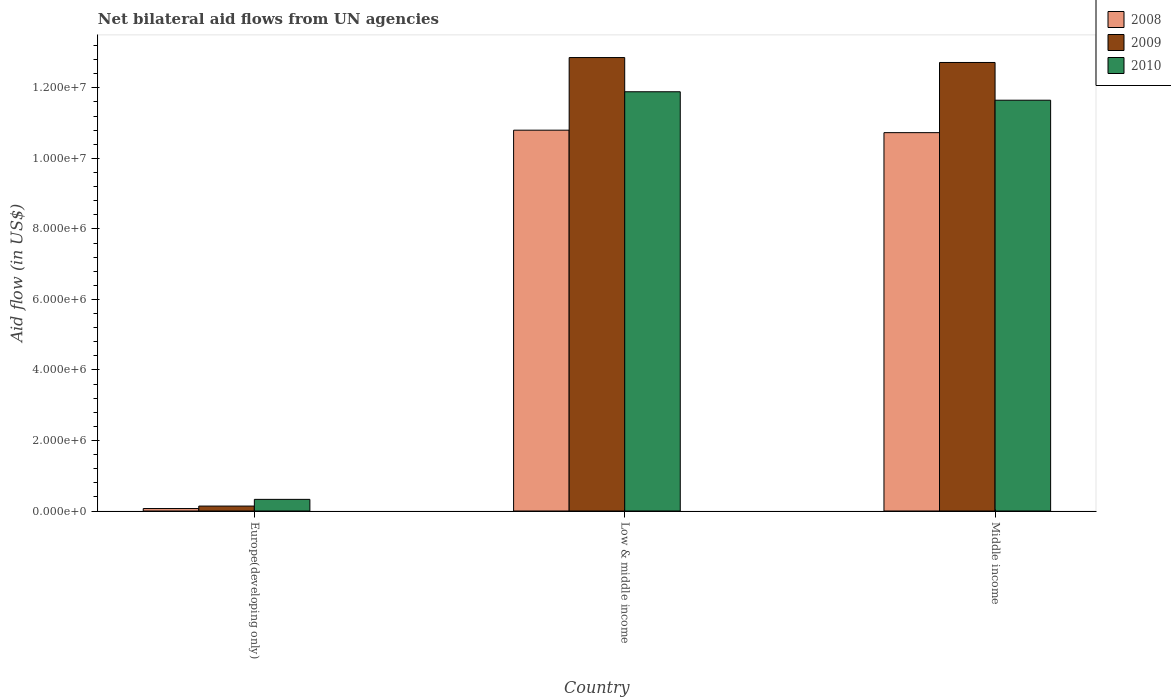How many bars are there on the 1st tick from the right?
Ensure brevity in your answer.  3. In how many cases, is the number of bars for a given country not equal to the number of legend labels?
Provide a succinct answer. 0. What is the net bilateral aid flow in 2008 in Middle income?
Keep it short and to the point. 1.07e+07. Across all countries, what is the maximum net bilateral aid flow in 2009?
Make the answer very short. 1.29e+07. In which country was the net bilateral aid flow in 2008 minimum?
Keep it short and to the point. Europe(developing only). What is the total net bilateral aid flow in 2008 in the graph?
Your response must be concise. 2.16e+07. What is the difference between the net bilateral aid flow in 2009 in Europe(developing only) and that in Low & middle income?
Give a very brief answer. -1.27e+07. What is the difference between the net bilateral aid flow in 2008 in Middle income and the net bilateral aid flow in 2010 in Low & middle income?
Your answer should be very brief. -1.16e+06. What is the average net bilateral aid flow in 2010 per country?
Make the answer very short. 7.96e+06. What is the difference between the net bilateral aid flow of/in 2010 and net bilateral aid flow of/in 2009 in Middle income?
Make the answer very short. -1.07e+06. What is the ratio of the net bilateral aid flow in 2010 in Low & middle income to that in Middle income?
Give a very brief answer. 1.02. Is the net bilateral aid flow in 2008 in Europe(developing only) less than that in Middle income?
Ensure brevity in your answer.  Yes. Is the difference between the net bilateral aid flow in 2010 in Low & middle income and Middle income greater than the difference between the net bilateral aid flow in 2009 in Low & middle income and Middle income?
Give a very brief answer. Yes. What is the difference between the highest and the second highest net bilateral aid flow in 2009?
Give a very brief answer. 1.27e+07. What is the difference between the highest and the lowest net bilateral aid flow in 2008?
Offer a very short reply. 1.07e+07. In how many countries, is the net bilateral aid flow in 2009 greater than the average net bilateral aid flow in 2009 taken over all countries?
Offer a terse response. 2. Is the sum of the net bilateral aid flow in 2010 in Low & middle income and Middle income greater than the maximum net bilateral aid flow in 2009 across all countries?
Your answer should be compact. Yes. What does the 1st bar from the left in Middle income represents?
Give a very brief answer. 2008. What does the 3rd bar from the right in Middle income represents?
Your answer should be very brief. 2008. How many bars are there?
Provide a short and direct response. 9. Are all the bars in the graph horizontal?
Offer a very short reply. No. How many countries are there in the graph?
Offer a very short reply. 3. What is the difference between two consecutive major ticks on the Y-axis?
Provide a short and direct response. 2.00e+06. Does the graph contain any zero values?
Offer a terse response. No. Where does the legend appear in the graph?
Offer a terse response. Top right. What is the title of the graph?
Offer a terse response. Net bilateral aid flows from UN agencies. What is the label or title of the Y-axis?
Provide a short and direct response. Aid flow (in US$). What is the Aid flow (in US$) of 2009 in Europe(developing only)?
Ensure brevity in your answer.  1.40e+05. What is the Aid flow (in US$) of 2010 in Europe(developing only)?
Make the answer very short. 3.30e+05. What is the Aid flow (in US$) in 2008 in Low & middle income?
Keep it short and to the point. 1.08e+07. What is the Aid flow (in US$) in 2009 in Low & middle income?
Your answer should be compact. 1.29e+07. What is the Aid flow (in US$) of 2010 in Low & middle income?
Your response must be concise. 1.19e+07. What is the Aid flow (in US$) of 2008 in Middle income?
Offer a terse response. 1.07e+07. What is the Aid flow (in US$) of 2009 in Middle income?
Offer a terse response. 1.27e+07. What is the Aid flow (in US$) of 2010 in Middle income?
Your response must be concise. 1.16e+07. Across all countries, what is the maximum Aid flow (in US$) of 2008?
Your response must be concise. 1.08e+07. Across all countries, what is the maximum Aid flow (in US$) in 2009?
Your response must be concise. 1.29e+07. Across all countries, what is the maximum Aid flow (in US$) in 2010?
Offer a very short reply. 1.19e+07. Across all countries, what is the minimum Aid flow (in US$) of 2010?
Give a very brief answer. 3.30e+05. What is the total Aid flow (in US$) in 2008 in the graph?
Provide a succinct answer. 2.16e+07. What is the total Aid flow (in US$) in 2009 in the graph?
Keep it short and to the point. 2.57e+07. What is the total Aid flow (in US$) of 2010 in the graph?
Your answer should be very brief. 2.39e+07. What is the difference between the Aid flow (in US$) of 2008 in Europe(developing only) and that in Low & middle income?
Offer a terse response. -1.07e+07. What is the difference between the Aid flow (in US$) in 2009 in Europe(developing only) and that in Low & middle income?
Your answer should be very brief. -1.27e+07. What is the difference between the Aid flow (in US$) in 2010 in Europe(developing only) and that in Low & middle income?
Keep it short and to the point. -1.16e+07. What is the difference between the Aid flow (in US$) of 2008 in Europe(developing only) and that in Middle income?
Your answer should be very brief. -1.07e+07. What is the difference between the Aid flow (in US$) of 2009 in Europe(developing only) and that in Middle income?
Give a very brief answer. -1.26e+07. What is the difference between the Aid flow (in US$) of 2010 in Europe(developing only) and that in Middle income?
Provide a succinct answer. -1.13e+07. What is the difference between the Aid flow (in US$) in 2008 in Low & middle income and that in Middle income?
Ensure brevity in your answer.  7.00e+04. What is the difference between the Aid flow (in US$) of 2009 in Low & middle income and that in Middle income?
Provide a short and direct response. 1.40e+05. What is the difference between the Aid flow (in US$) of 2010 in Low & middle income and that in Middle income?
Your answer should be very brief. 2.40e+05. What is the difference between the Aid flow (in US$) in 2008 in Europe(developing only) and the Aid flow (in US$) in 2009 in Low & middle income?
Your answer should be compact. -1.28e+07. What is the difference between the Aid flow (in US$) in 2008 in Europe(developing only) and the Aid flow (in US$) in 2010 in Low & middle income?
Make the answer very short. -1.18e+07. What is the difference between the Aid flow (in US$) in 2009 in Europe(developing only) and the Aid flow (in US$) in 2010 in Low & middle income?
Provide a short and direct response. -1.18e+07. What is the difference between the Aid flow (in US$) in 2008 in Europe(developing only) and the Aid flow (in US$) in 2009 in Middle income?
Provide a short and direct response. -1.26e+07. What is the difference between the Aid flow (in US$) of 2008 in Europe(developing only) and the Aid flow (in US$) of 2010 in Middle income?
Give a very brief answer. -1.16e+07. What is the difference between the Aid flow (in US$) of 2009 in Europe(developing only) and the Aid flow (in US$) of 2010 in Middle income?
Ensure brevity in your answer.  -1.15e+07. What is the difference between the Aid flow (in US$) of 2008 in Low & middle income and the Aid flow (in US$) of 2009 in Middle income?
Provide a short and direct response. -1.92e+06. What is the difference between the Aid flow (in US$) of 2008 in Low & middle income and the Aid flow (in US$) of 2010 in Middle income?
Give a very brief answer. -8.50e+05. What is the difference between the Aid flow (in US$) in 2009 in Low & middle income and the Aid flow (in US$) in 2010 in Middle income?
Your response must be concise. 1.21e+06. What is the average Aid flow (in US$) in 2008 per country?
Make the answer very short. 7.20e+06. What is the average Aid flow (in US$) of 2009 per country?
Offer a terse response. 8.57e+06. What is the average Aid flow (in US$) of 2010 per country?
Keep it short and to the point. 7.96e+06. What is the difference between the Aid flow (in US$) of 2008 and Aid flow (in US$) of 2009 in Europe(developing only)?
Keep it short and to the point. -7.00e+04. What is the difference between the Aid flow (in US$) of 2009 and Aid flow (in US$) of 2010 in Europe(developing only)?
Your response must be concise. -1.90e+05. What is the difference between the Aid flow (in US$) of 2008 and Aid flow (in US$) of 2009 in Low & middle income?
Offer a very short reply. -2.06e+06. What is the difference between the Aid flow (in US$) of 2008 and Aid flow (in US$) of 2010 in Low & middle income?
Make the answer very short. -1.09e+06. What is the difference between the Aid flow (in US$) of 2009 and Aid flow (in US$) of 2010 in Low & middle income?
Give a very brief answer. 9.70e+05. What is the difference between the Aid flow (in US$) in 2008 and Aid flow (in US$) in 2009 in Middle income?
Your answer should be very brief. -1.99e+06. What is the difference between the Aid flow (in US$) in 2008 and Aid flow (in US$) in 2010 in Middle income?
Your response must be concise. -9.20e+05. What is the difference between the Aid flow (in US$) of 2009 and Aid flow (in US$) of 2010 in Middle income?
Offer a very short reply. 1.07e+06. What is the ratio of the Aid flow (in US$) in 2008 in Europe(developing only) to that in Low & middle income?
Your response must be concise. 0.01. What is the ratio of the Aid flow (in US$) of 2009 in Europe(developing only) to that in Low & middle income?
Give a very brief answer. 0.01. What is the ratio of the Aid flow (in US$) of 2010 in Europe(developing only) to that in Low & middle income?
Offer a terse response. 0.03. What is the ratio of the Aid flow (in US$) in 2008 in Europe(developing only) to that in Middle income?
Provide a succinct answer. 0.01. What is the ratio of the Aid flow (in US$) in 2009 in Europe(developing only) to that in Middle income?
Your response must be concise. 0.01. What is the ratio of the Aid flow (in US$) of 2010 in Europe(developing only) to that in Middle income?
Ensure brevity in your answer.  0.03. What is the ratio of the Aid flow (in US$) in 2010 in Low & middle income to that in Middle income?
Provide a short and direct response. 1.02. What is the difference between the highest and the second highest Aid flow (in US$) in 2009?
Ensure brevity in your answer.  1.40e+05. What is the difference between the highest and the lowest Aid flow (in US$) in 2008?
Offer a very short reply. 1.07e+07. What is the difference between the highest and the lowest Aid flow (in US$) of 2009?
Give a very brief answer. 1.27e+07. What is the difference between the highest and the lowest Aid flow (in US$) in 2010?
Offer a terse response. 1.16e+07. 